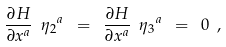Convert formula to latex. <formula><loc_0><loc_0><loc_500><loc_500>\frac { \partial H } { \partial x ^ { a } } \ { \eta _ { 2 } } ^ { a } \ = \ \frac { \partial H } { \partial x ^ { a } } \ { \eta _ { 3 } } ^ { a } \ = \ 0 \ ,</formula> 